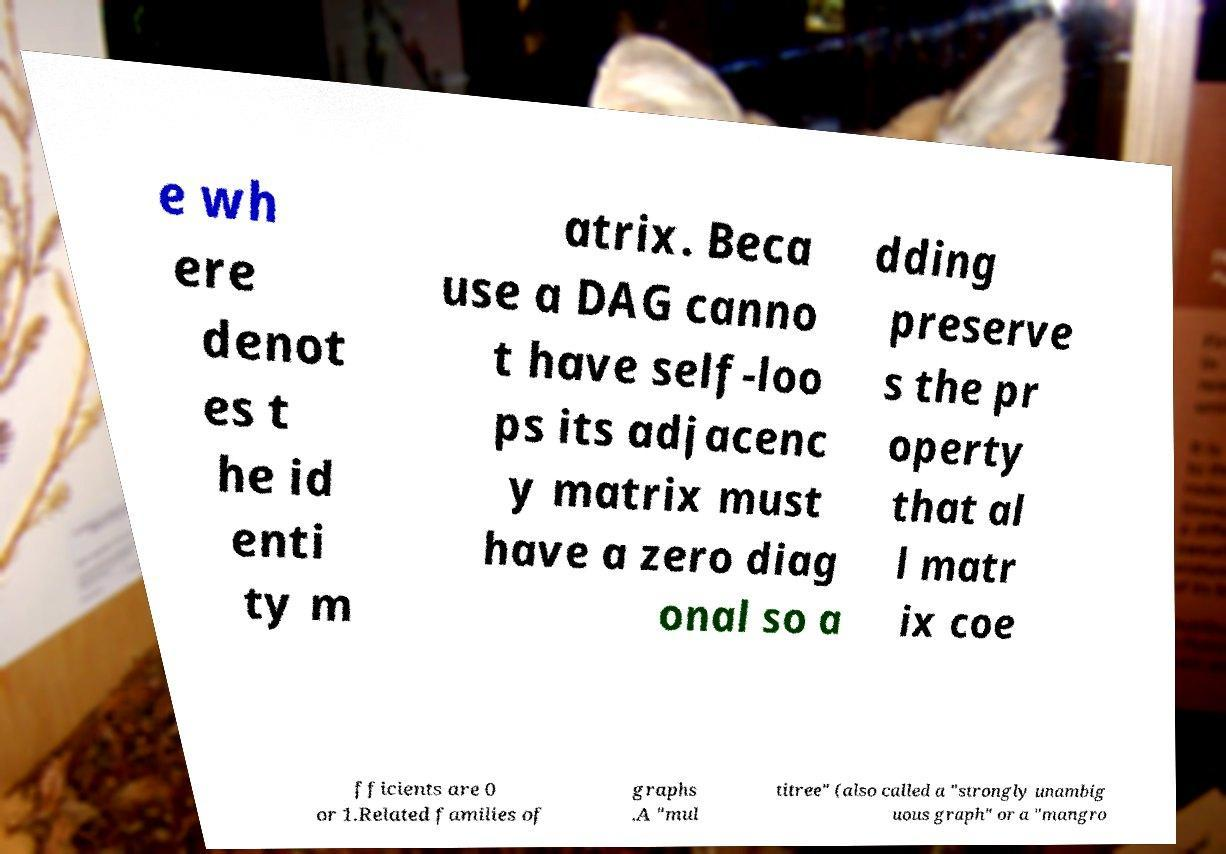There's text embedded in this image that I need extracted. Can you transcribe it verbatim? e wh ere denot es t he id enti ty m atrix. Beca use a DAG canno t have self-loo ps its adjacenc y matrix must have a zero diag onal so a dding preserve s the pr operty that al l matr ix coe fficients are 0 or 1.Related families of graphs .A "mul titree" (also called a "strongly unambig uous graph" or a "mangro 